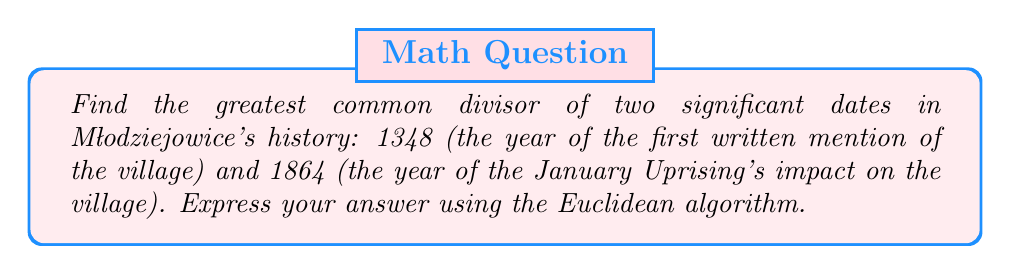Could you help me with this problem? To find the greatest common divisor (GCD) of 1348 and 1864 using the Euclidean algorithm, we follow these steps:

1) First, set up the initial equation:
   $$1864 = 1 \times 1348 + 516$$

2) Then, continue dividing the divisor by the remainder:
   $$1348 = 2 \times 516 + 316$$
   $$516 = 1 \times 316 + 200$$
   $$316 = 1 \times 200 + 116$$
   $$200 = 1 \times 116 + 84$$
   $$116 = 1 \times 84 + 32$$
   $$84 = 2 \times 32 + 20$$
   $$32 = 1 \times 20 + 12$$
   $$20 = 1 \times 12 + 8$$
   $$12 = 1 \times 8 + 4$$
   $$8 = 2 \times 4 + 0$$

3) The process stops when we get a remainder of 0. The last non-zero remainder is the GCD.

Therefore, the greatest common divisor of 1348 and 1864 is 4.
Answer: $\gcd(1348, 1864) = 4$ 